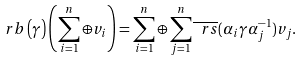<formula> <loc_0><loc_0><loc_500><loc_500>\ r b \left ( \gamma \right ) \left ( \sum _ { i = 1 } ^ { n } \oplus v _ { i } \right ) = \sum _ { i = 1 } ^ { n } \oplus \sum _ { j = 1 } ^ { n } \overline { \ r s } ( \alpha _ { i } \gamma \alpha _ { j } ^ { - 1 } ) v _ { j } .</formula> 